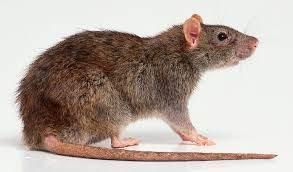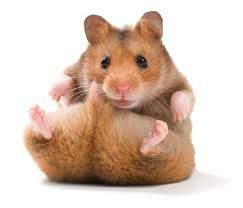The first image is the image on the left, the second image is the image on the right. Analyze the images presented: Is the assertion "At least one of the animals is interacting with something." valid? Answer yes or no. No. The first image is the image on the left, the second image is the image on the right. For the images displayed, is the sentence "THere are at least two hamsters in the image on the right." factually correct? Answer yes or no. No. 